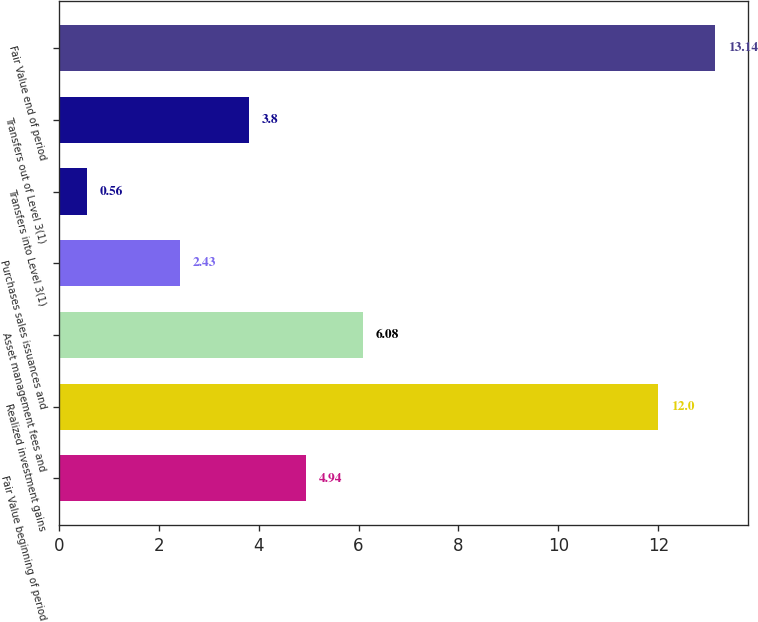Convert chart to OTSL. <chart><loc_0><loc_0><loc_500><loc_500><bar_chart><fcel>Fair Value beginning of period<fcel>Realized investment gains<fcel>Asset management fees and<fcel>Purchases sales issuances and<fcel>Transfers into Level 3(1)<fcel>Transfers out of Level 3(1)<fcel>Fair Value end of period<nl><fcel>4.94<fcel>12<fcel>6.08<fcel>2.43<fcel>0.56<fcel>3.8<fcel>13.14<nl></chart> 